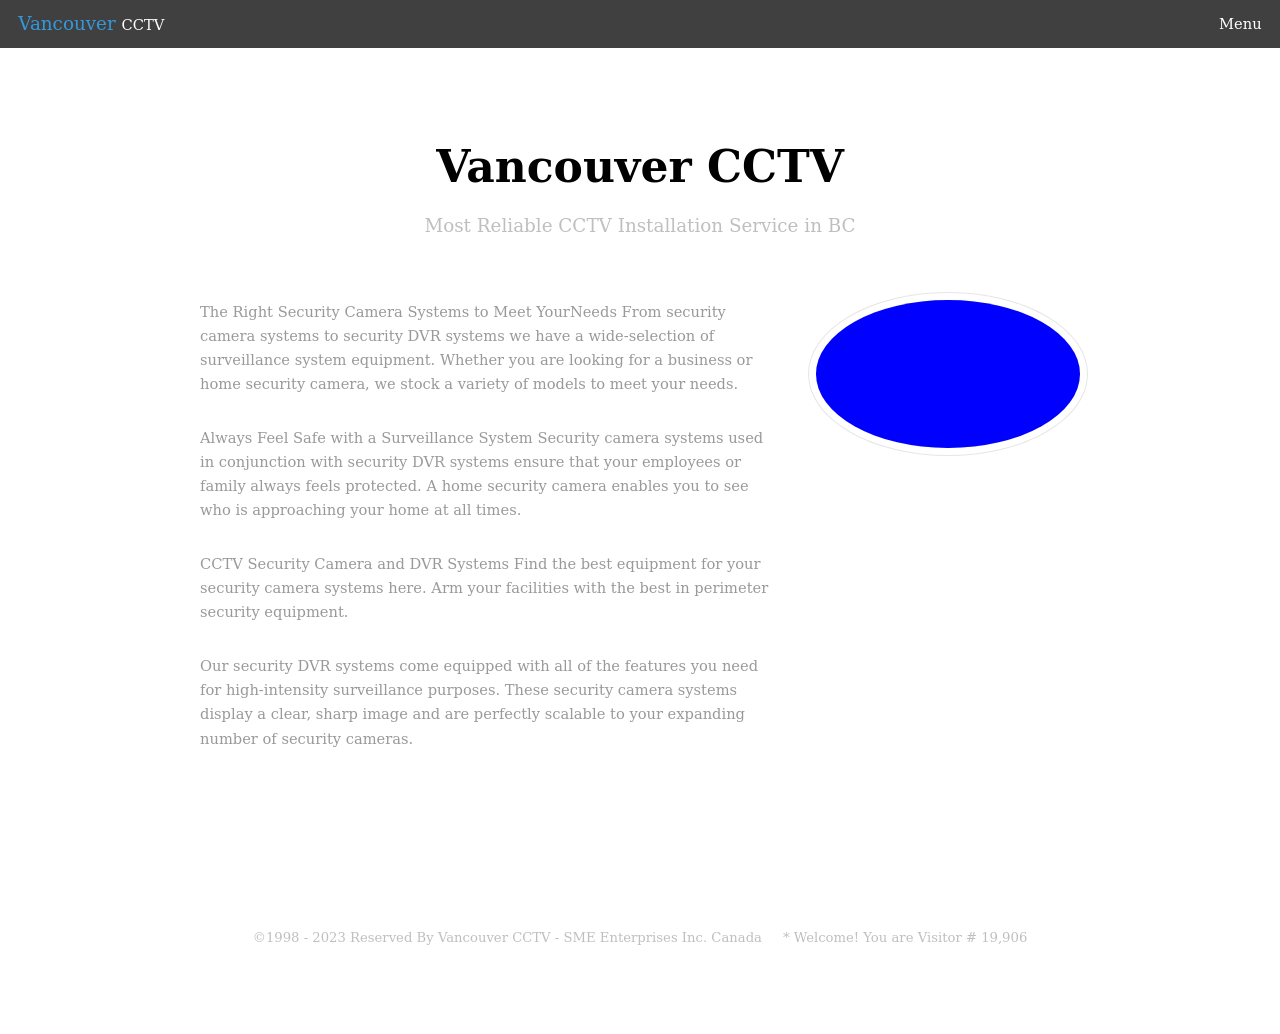What's the procedure for constructing this website from scratch with HTML? To construct a website similar to the one shown in the image from scratch using HTML, you would begin by creating a basic HTML structure. This includes defining the <!DOCTYPE html>, <html>, <head>, and <body> tags. Inside the <head>, you would typically include <title> tags and links to any CSS files for styling. The <body> contains all the visible parts of the website, such as the header, navigation menu, sections for content, and the footer. Each section can be marked up using <div> or semantic HTML5 elements like <header>, <nav>, <section>, and <footer>. To replicate the clean and professional design seen in the image, additional CSS would be required to style these elements appropriately, focusing on layout, color schemes, typography, and other visual elements. 